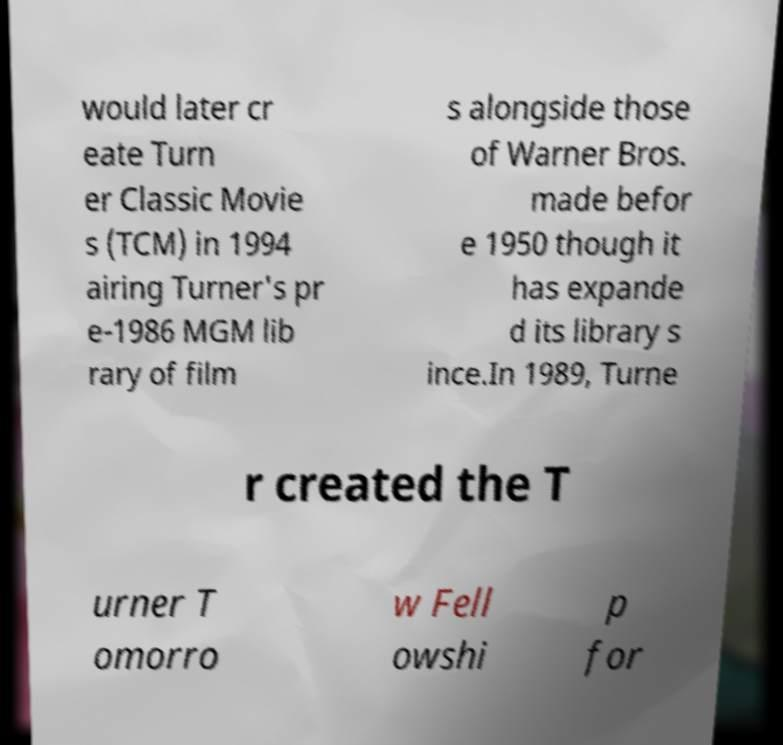For documentation purposes, I need the text within this image transcribed. Could you provide that? would later cr eate Turn er Classic Movie s (TCM) in 1994 airing Turner's pr e-1986 MGM lib rary of film s alongside those of Warner Bros. made befor e 1950 though it has expande d its library s ince.In 1989, Turne r created the T urner T omorro w Fell owshi p for 